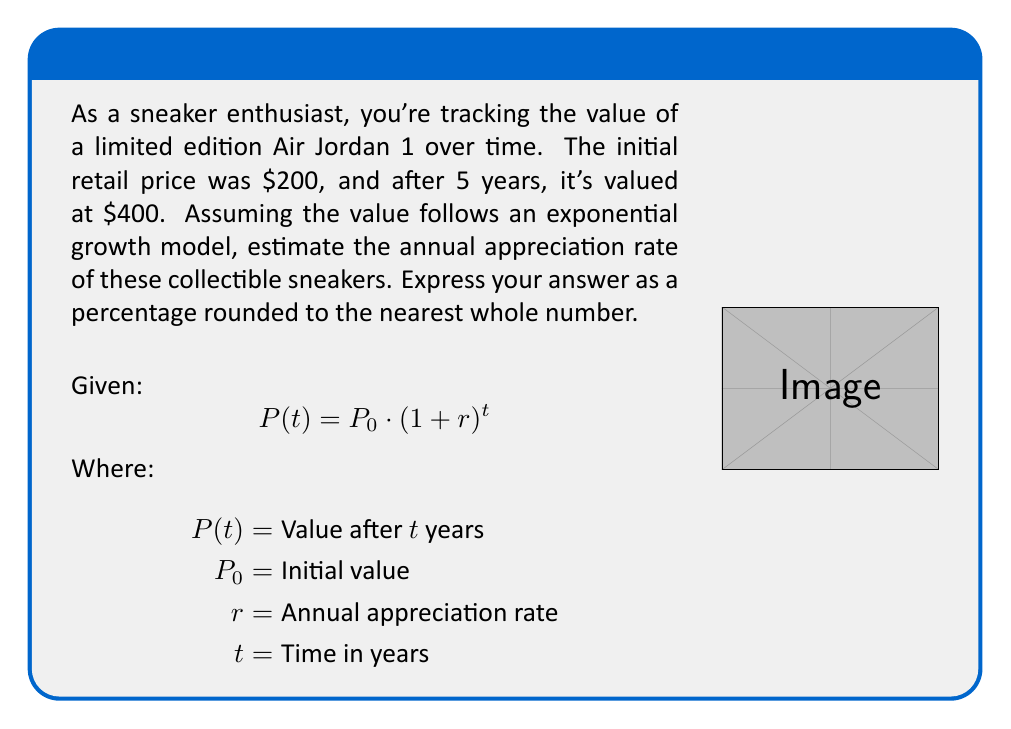Could you help me with this problem? Let's solve this step-by-step:

1) We know:
   $P_0 = $200$ (initial retail price)
   $P(5) = $400$ (value after 5 years)
   $t = 5$ years

2) Plug these into the exponential growth formula:
   $$400 = 200 \cdot (1 + r)^5$$

3) Divide both sides by 200:
   $$2 = (1 + r)^5$$

4) Take the 5th root of both sides:
   $$\sqrt[5]{2} = 1 + r$$

5) Subtract 1 from both sides:
   $$\sqrt[5]{2} - 1 = r$$

6) Calculate:
   $$r \approx 1.1487 - 1 = 0.1487$$

7) Convert to a percentage:
   $$0.1487 \times 100 \approx 14.87\%$$

8) Round to the nearest whole number:
   $$14.87\% \approx 15\%$$

Note: This is actually the appreciation rate. To get the depreciation rate, we would need to negate this value.
Answer: 15% 